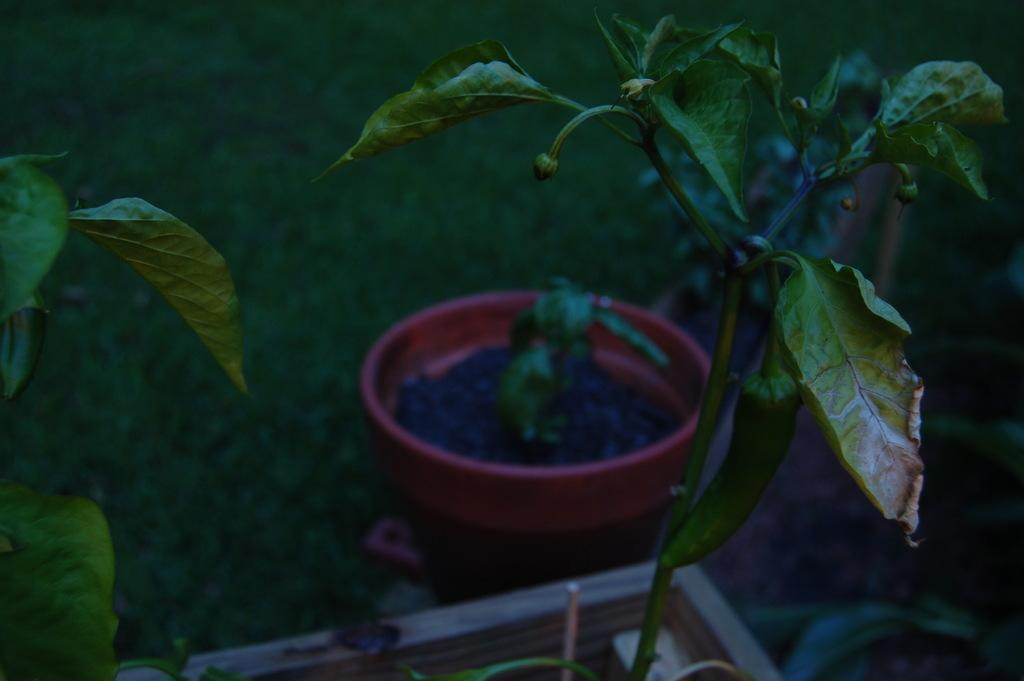What type of plant is in the middle of the image? There is a chilli plant in the middle of the image. What can be seen in the background of the image? There is a flower pot in the background of the image. Where is the flower pot located? The flower pot is on the ground. Can you see a giraffe playing a guitar in the image? No, there is no giraffe or guitar present in the image. 